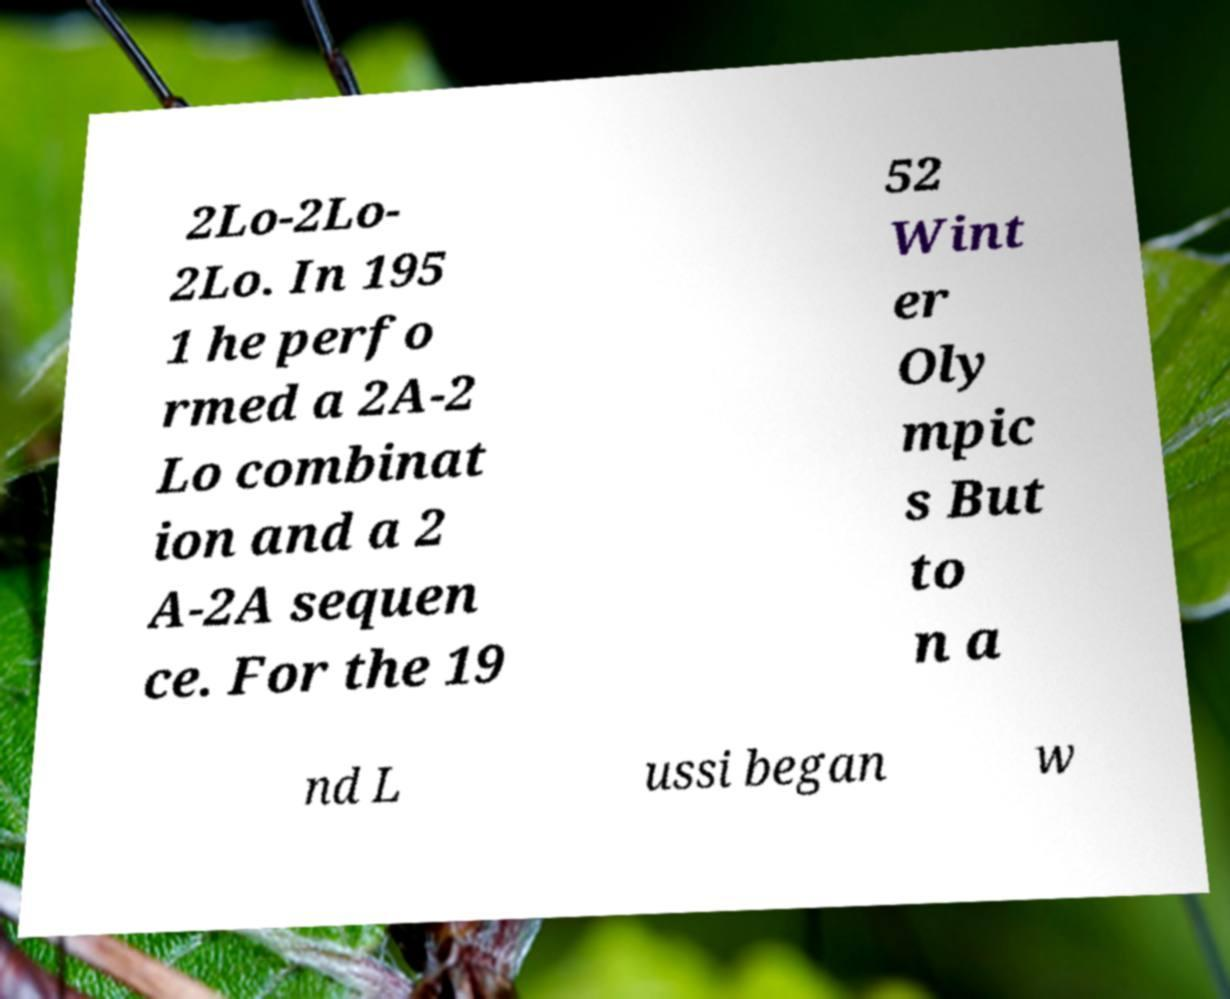Could you assist in decoding the text presented in this image and type it out clearly? 2Lo-2Lo- 2Lo. In 195 1 he perfo rmed a 2A-2 Lo combinat ion and a 2 A-2A sequen ce. For the 19 52 Wint er Oly mpic s But to n a nd L ussi began w 